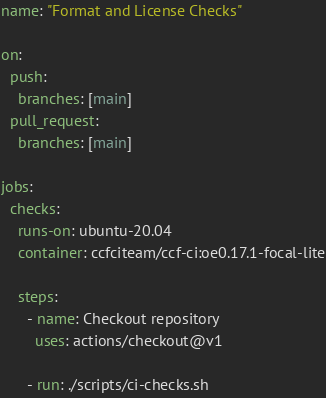Convert code to text. <code><loc_0><loc_0><loc_500><loc_500><_YAML_>name: "Format and License Checks"

on:
  push:
    branches: [main]
  pull_request:
    branches: [main]

jobs:
  checks:
    runs-on: ubuntu-20.04
    container: ccfciteam/ccf-ci:oe0.17.1-focal-lite

    steps:
      - name: Checkout repository
        uses: actions/checkout@v1

      - run: ./scripts/ci-checks.sh
</code> 